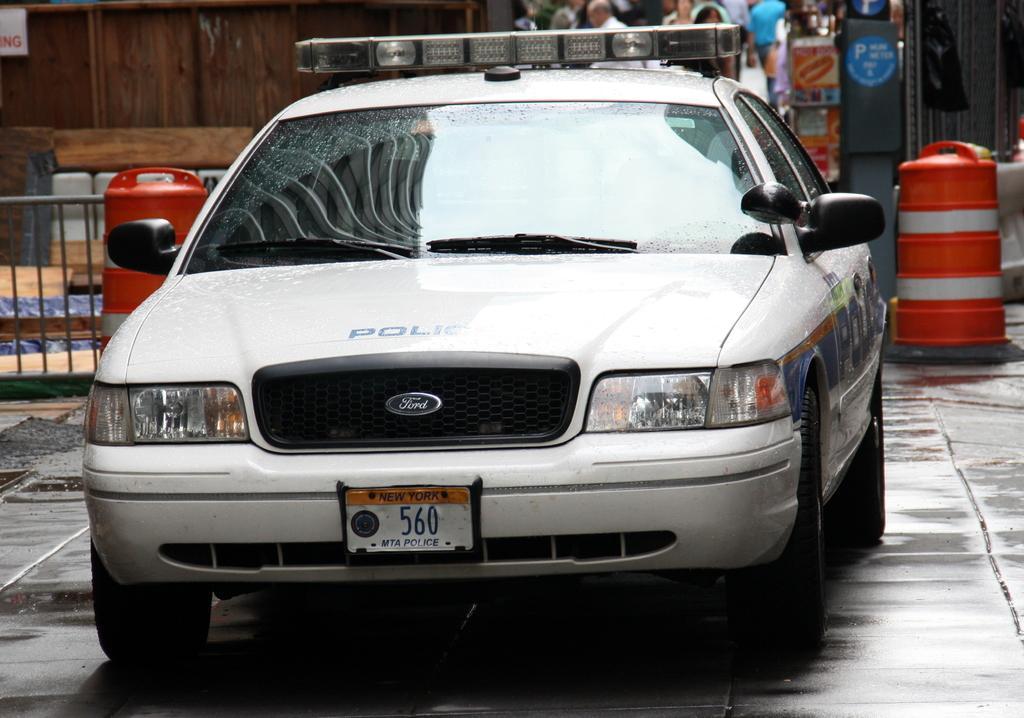Please provide a concise description of this image. In this image we can see a car. And can see the metal fence. And we can see the wooden wall. And we can see some other wooden objects. 